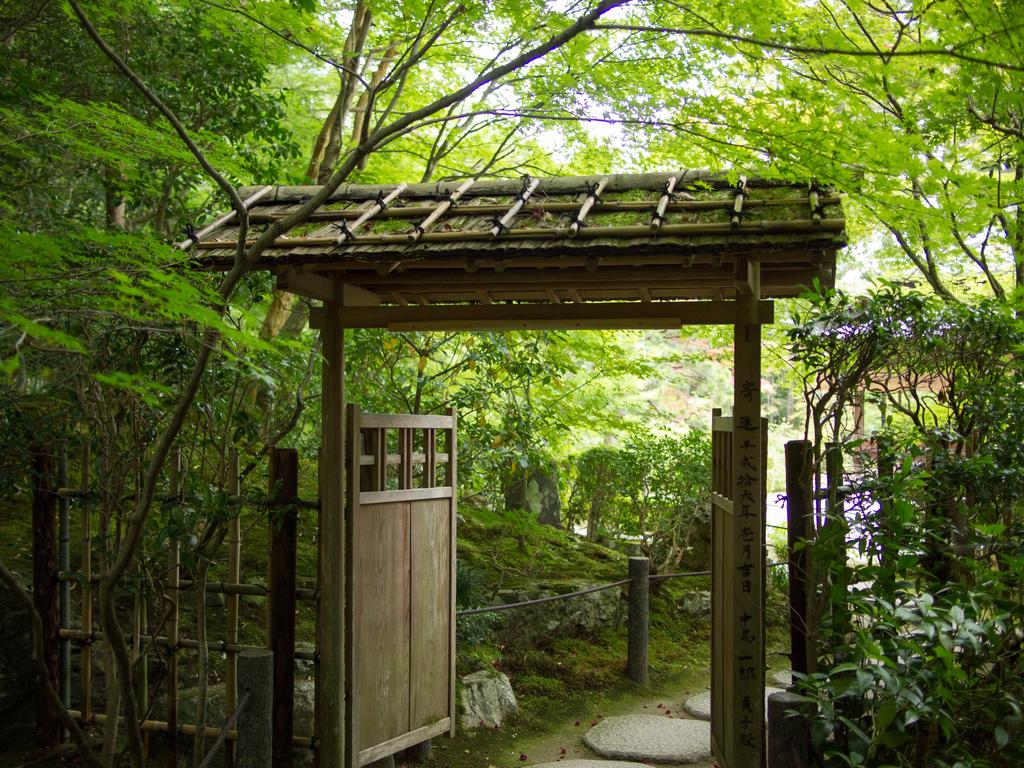What is the main feature of the entrance in the image? There is a gate in the image. What type of natural elements can be seen in the image? There are trees and plants in the image. What can be seen on the ground in the image? The ground is visible in the image. What type of barrier is present in the image? There is fencing in the image. What part of the natural environment is visible in the image? The sky is visible in the image. How many trucks are parked near the entrance in the image? There are no trucks present in the image. Can you describe how the plants in the image are moving? The plants in the image are not moving; they are stationary. 